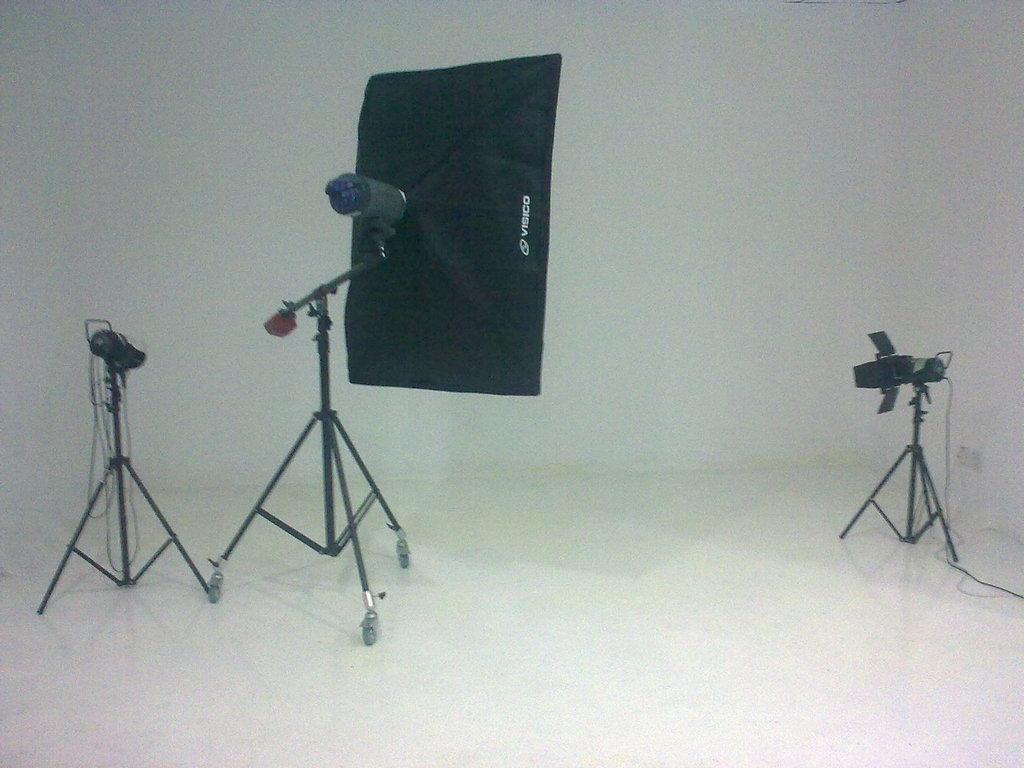In one or two sentences, can you explain what this image depicts? In this image I can see a softbox. I can see two cameras. The background is white in color. 